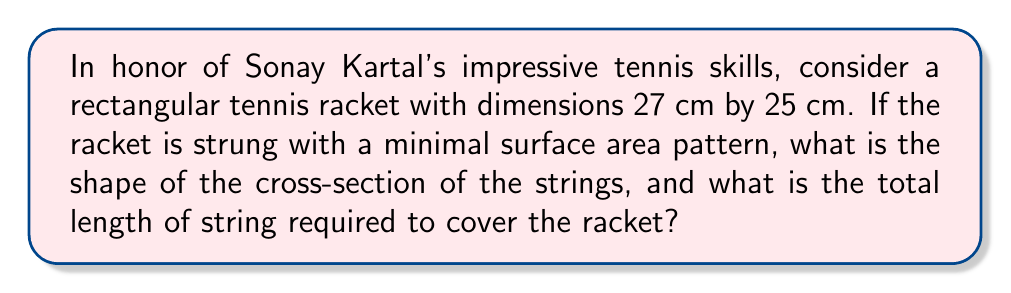Teach me how to tackle this problem. To solve this problem, we'll follow these steps:

1) The minimal surface area for a given boundary is achieved by a catenoid, which is a surface of revolution of a catenary curve.

2) The catenary curve is given by the equation:

   $$y = a \cosh(\frac{x}{a})$$

   where $a$ is a constant that determines the shape of the curve.

3) For a tennis racket, we need to consider a periodic pattern of catenaries. Let's assume the strings are spaced 1 cm apart.

4) The boundary conditions for our catenary are:

   $$y(0) = y(1) = 0$$

5) Solving this, we get:

   $$a \cosh(0) = a \cosh(\frac{1}{a}) = 0$$

   $$\cosh(\frac{1}{a}) = 1$$

   $$\frac{1}{a} = \text{arccosh}(1) \approx 1.3170$$

   $$a \approx 0.7592$$

6) Now, the length of a catenary curve is given by:

   $$L = 2a \sinh(\frac{1}{2a}) \approx 1.0006$$

7) For the 27 cm length, we need 26 strings, and for the 25 cm width, we need 24 strings.

8) Total length = $(26 * 25 + 24 * 27) * 1.0006 = 2301.38$ cm

[asy]
import graph;
size(200,100);
real f(real x) {return 0.7592*cosh(x/0.7592);}
draw(graph(f,-0.5,1.5));
draw((0,0)--(1,0),red);
label("1 cm",(.5,-.1),S);
[/asy]
Answer: Catenary cross-section; 2301.38 cm of string 